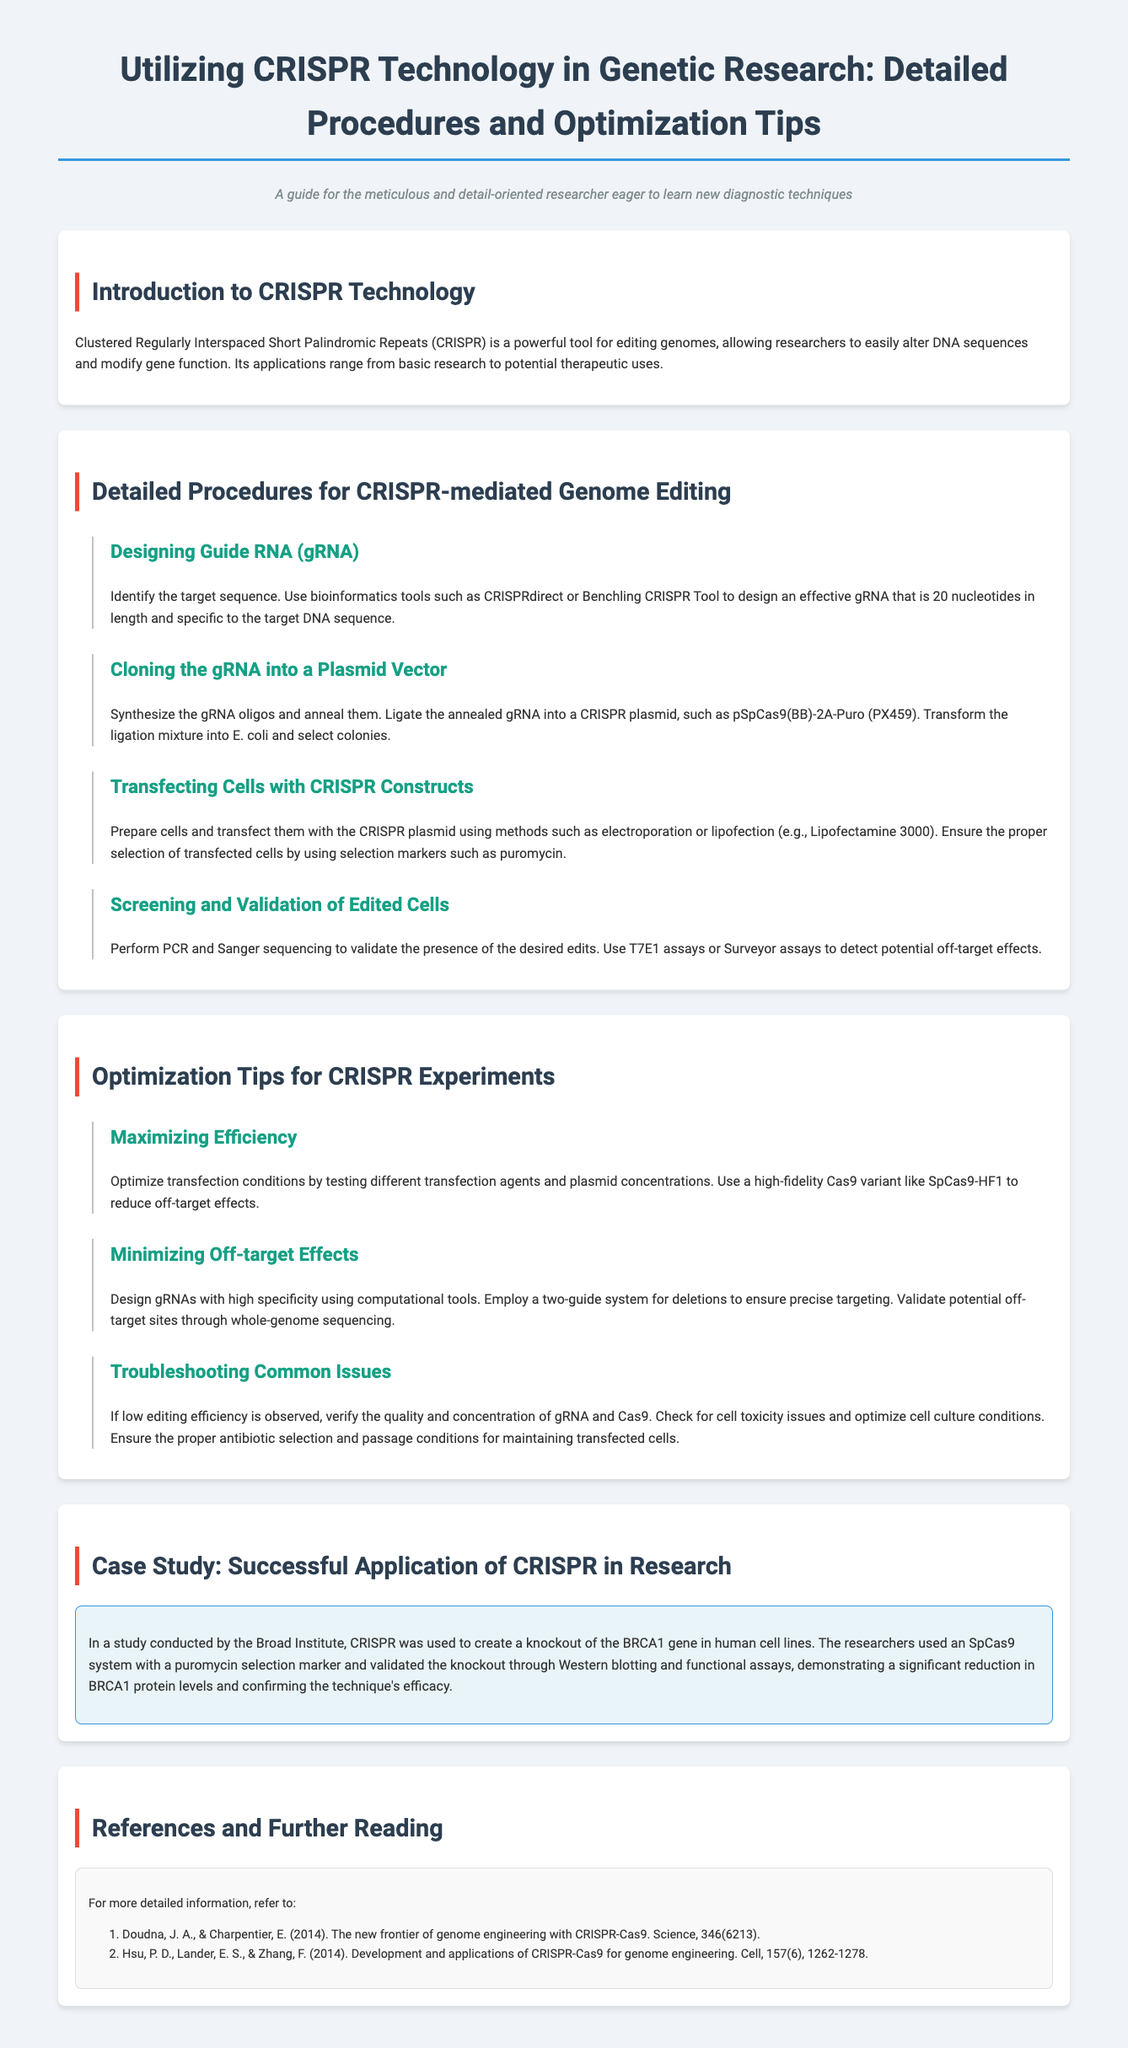What is CRISPR? CRISPR is described as a powerful tool for editing genomes, allowing researchers to easily alter DNA sequences and modify gene function.
Answer: A powerful tool for editing genomes What is the length of the effective gRNA? The document specifies that the effective gRNA should be specific to the target DNA sequence and is 20 nucleotides in length.
Answer: 20 nucleotides What plasmid is mentioned for cloning gRNA? The guide mentions using a specific plasmid for cloning, which is identified in the text as pSpCas9(BB)-2A-Puro (PX459).
Answer: pSpCas9(BB)-2A-Puro (PX459) Which transfection method is mentioned for cells? The document suggests several methods for transfecting cells, one of which is Lipofectamine 3000.
Answer: Lipofectamine 3000 What is a key application of CRISPR technology mentioned in the case study? The case study provides an example of using CRISPR to create a knockout of the BRCA1 gene in human cell lines.
Answer: Knockout of the BRCA1 gene What is the purpose of using selection markers in transfection? The text indicates that selection markers are used to ensure the proper selection of transfected cells during the process.
Answer: Ensure proper selection of transfected cells Which assay is mentioned for detecting off-target effects? The document refers to the T7E1 assay as a method for detecting potential off-target effects in edited cells.
Answer: T7E1 assay What should be verified if low editing efficiency is observed? According to the guide, one should verify the quality and concentration of gRNA and Cas9 if low editing efficiency is observed.
Answer: Quality and concentration of gRNA and Cas9 What is one optimization technique suggested in the document? The document advises optimizing transfection conditions by testing different transfection agents and plasmid concentrations to maximize efficiency.
Answer: Testing different transfection agents and plasmid concentrations 